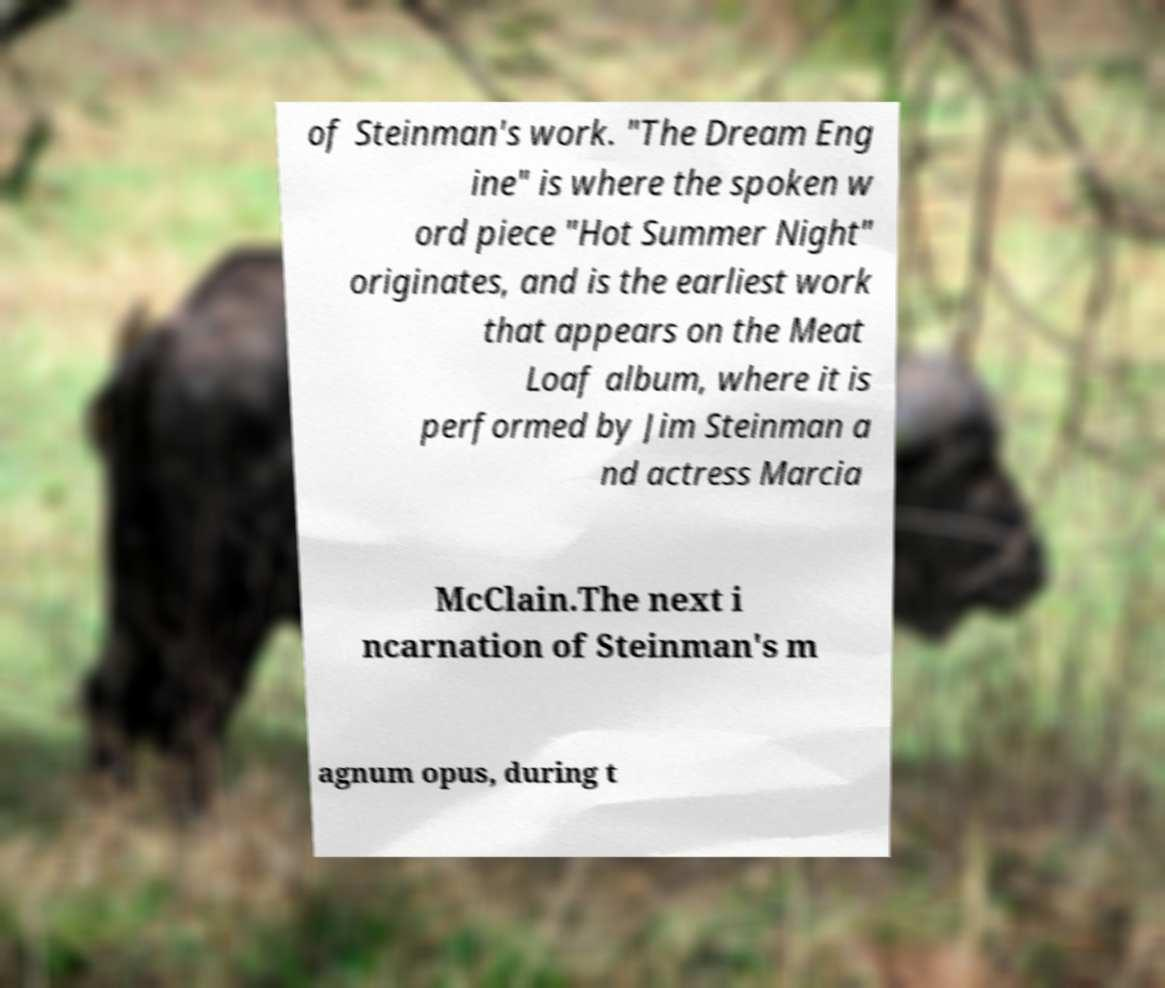Can you read and provide the text displayed in the image?This photo seems to have some interesting text. Can you extract and type it out for me? of Steinman's work. "The Dream Eng ine" is where the spoken w ord piece "Hot Summer Night" originates, and is the earliest work that appears on the Meat Loaf album, where it is performed by Jim Steinman a nd actress Marcia McClain.The next i ncarnation of Steinman's m agnum opus, during t 